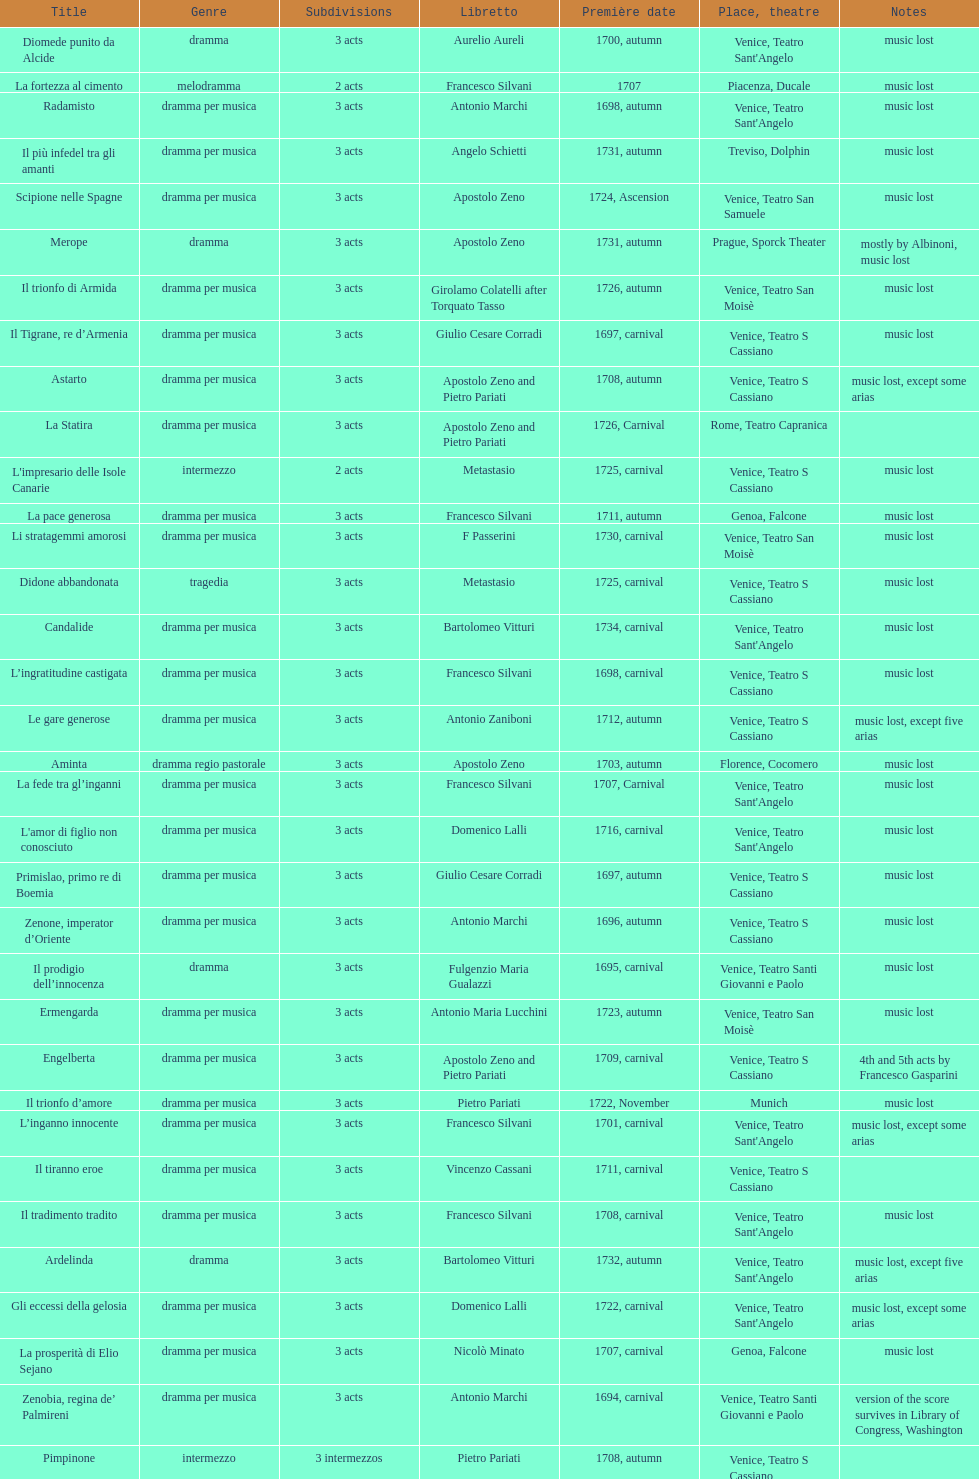What is next after ardelinda? Candalide. 